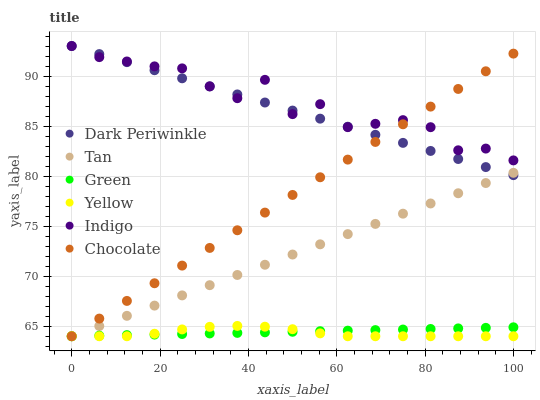Does Yellow have the minimum area under the curve?
Answer yes or no. Yes. Does Indigo have the maximum area under the curve?
Answer yes or no. Yes. Does Chocolate have the minimum area under the curve?
Answer yes or no. No. Does Chocolate have the maximum area under the curve?
Answer yes or no. No. Is Chocolate the smoothest?
Answer yes or no. Yes. Is Indigo the roughest?
Answer yes or no. Yes. Is Yellow the smoothest?
Answer yes or no. No. Is Yellow the roughest?
Answer yes or no. No. Does Yellow have the lowest value?
Answer yes or no. Yes. Does Dark Periwinkle have the lowest value?
Answer yes or no. No. Does Dark Periwinkle have the highest value?
Answer yes or no. Yes. Does Yellow have the highest value?
Answer yes or no. No. Is Yellow less than Dark Periwinkle?
Answer yes or no. Yes. Is Dark Periwinkle greater than Green?
Answer yes or no. Yes. Does Chocolate intersect Yellow?
Answer yes or no. Yes. Is Chocolate less than Yellow?
Answer yes or no. No. Is Chocolate greater than Yellow?
Answer yes or no. No. Does Yellow intersect Dark Periwinkle?
Answer yes or no. No. 